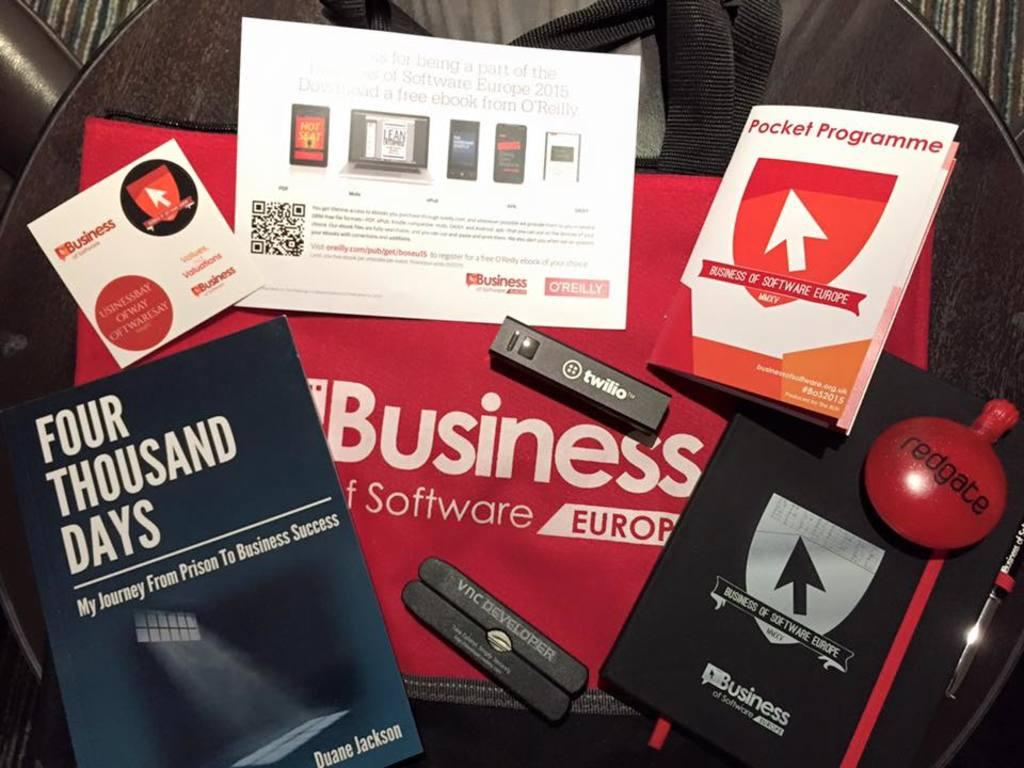<image>
Create a compact narrative representing the image presented. Red "Business" bag on top of the table is covered with books, pamphlets and things. 